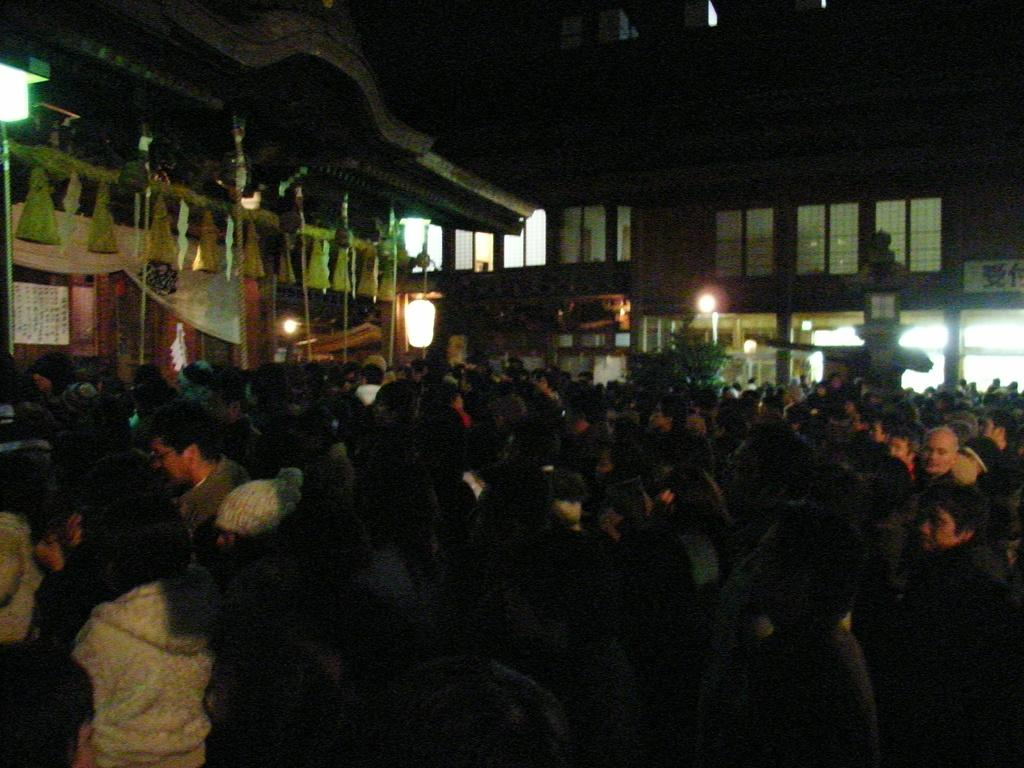How many people are in the image? There is a group of people in the image. What is the position of the people in the image? The people are standing on the ground. What can be seen in the distance behind the people? There are buildings, lights, and other objects visible in the background of the image. What is the tendency of the apple in the image? There is no apple present in the image, so it is not possible to determine its tendency. 